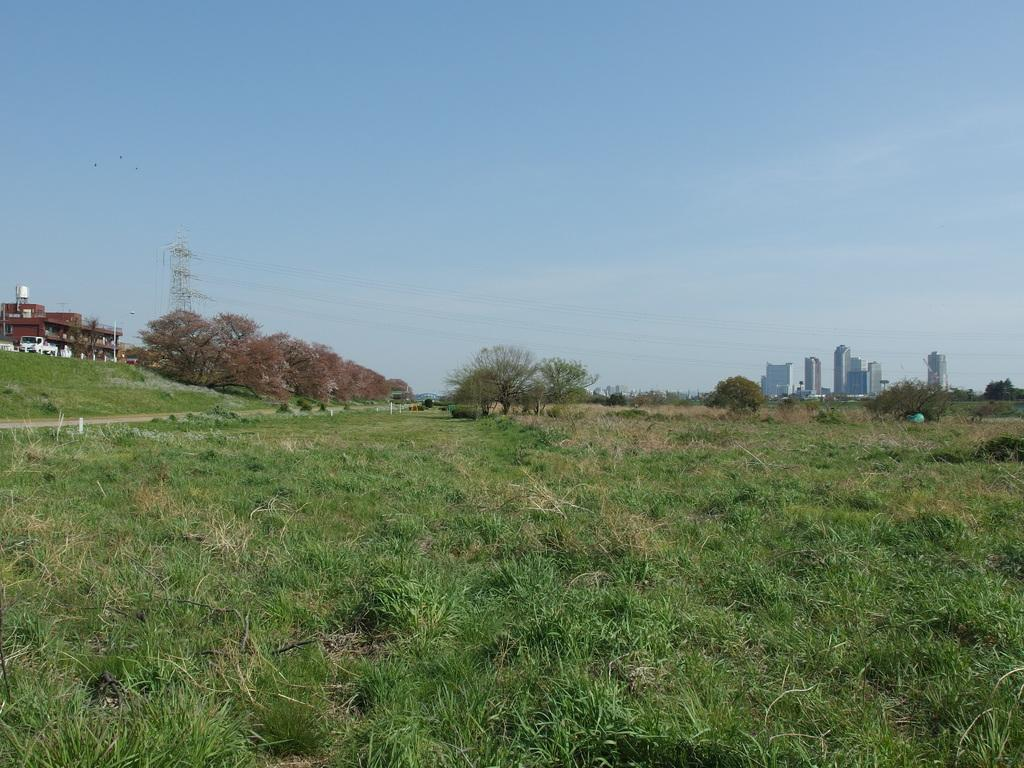What type of vegetation is on the ground in the image? There is grass on the ground in the image. What can be seen in the background of the image? There are trees and buildings in the background of the image. What is visible in the sky in the image? The sky is visible in the background of the image. What type of mouth can be seen on the tree in the image? There are no mouths present on the trees in the image, as trees do not have mouths. 